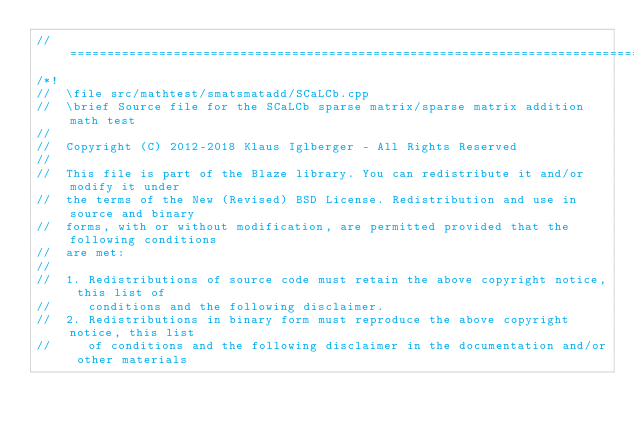<code> <loc_0><loc_0><loc_500><loc_500><_C++_>//=================================================================================================
/*!
//  \file src/mathtest/smatsmatadd/SCaLCb.cpp
//  \brief Source file for the SCaLCb sparse matrix/sparse matrix addition math test
//
//  Copyright (C) 2012-2018 Klaus Iglberger - All Rights Reserved
//
//  This file is part of the Blaze library. You can redistribute it and/or modify it under
//  the terms of the New (Revised) BSD License. Redistribution and use in source and binary
//  forms, with or without modification, are permitted provided that the following conditions
//  are met:
//
//  1. Redistributions of source code must retain the above copyright notice, this list of
//     conditions and the following disclaimer.
//  2. Redistributions in binary form must reproduce the above copyright notice, this list
//     of conditions and the following disclaimer in the documentation and/or other materials</code> 